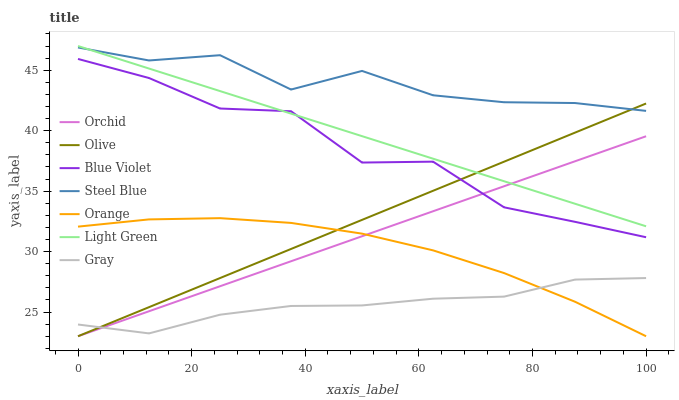Does Gray have the minimum area under the curve?
Answer yes or no. Yes. Does Steel Blue have the maximum area under the curve?
Answer yes or no. Yes. Does Orange have the minimum area under the curve?
Answer yes or no. No. Does Orange have the maximum area under the curve?
Answer yes or no. No. Is Olive the smoothest?
Answer yes or no. Yes. Is Blue Violet the roughest?
Answer yes or no. Yes. Is Steel Blue the smoothest?
Answer yes or no. No. Is Steel Blue the roughest?
Answer yes or no. No. Does Orange have the lowest value?
Answer yes or no. Yes. Does Steel Blue have the lowest value?
Answer yes or no. No. Does Light Green have the highest value?
Answer yes or no. Yes. Does Steel Blue have the highest value?
Answer yes or no. No. Is Orange less than Steel Blue?
Answer yes or no. Yes. Is Light Green greater than Orange?
Answer yes or no. Yes. Does Gray intersect Olive?
Answer yes or no. Yes. Is Gray less than Olive?
Answer yes or no. No. Is Gray greater than Olive?
Answer yes or no. No. Does Orange intersect Steel Blue?
Answer yes or no. No. 